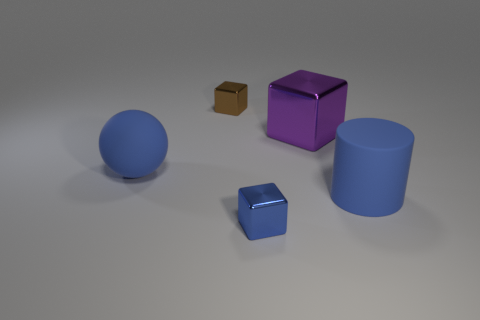Does the tiny cube in front of the large purple thing have the same material as the blue cylinder?
Provide a succinct answer. No. There is a blue thing that is in front of the big blue matte object that is in front of the rubber object on the left side of the small brown object; what is its material?
Your answer should be very brief. Metal. How many rubber things are purple cubes or tiny things?
Offer a terse response. 0. Are any small red blocks visible?
Keep it short and to the point. No. There is a shiny object in front of the big blue object right of the big matte ball; what is its color?
Ensure brevity in your answer.  Blue. How many other objects are the same color as the large shiny thing?
Your response must be concise. 0. How many objects are either tiny blue things or large things that are to the left of the big cylinder?
Your answer should be compact. 3. What color is the object that is in front of the big rubber cylinder?
Provide a succinct answer. Blue. There is a big purple shiny thing; what shape is it?
Offer a terse response. Cube. What material is the blue thing that is in front of the large matte cylinder in front of the large purple block made of?
Give a very brief answer. Metal. 